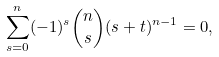Convert formula to latex. <formula><loc_0><loc_0><loc_500><loc_500>\sum _ { s = 0 } ^ { n } ( - 1 ) ^ { s } \binom { n } { s } ( s + t ) ^ { n - 1 } = 0 ,</formula> 